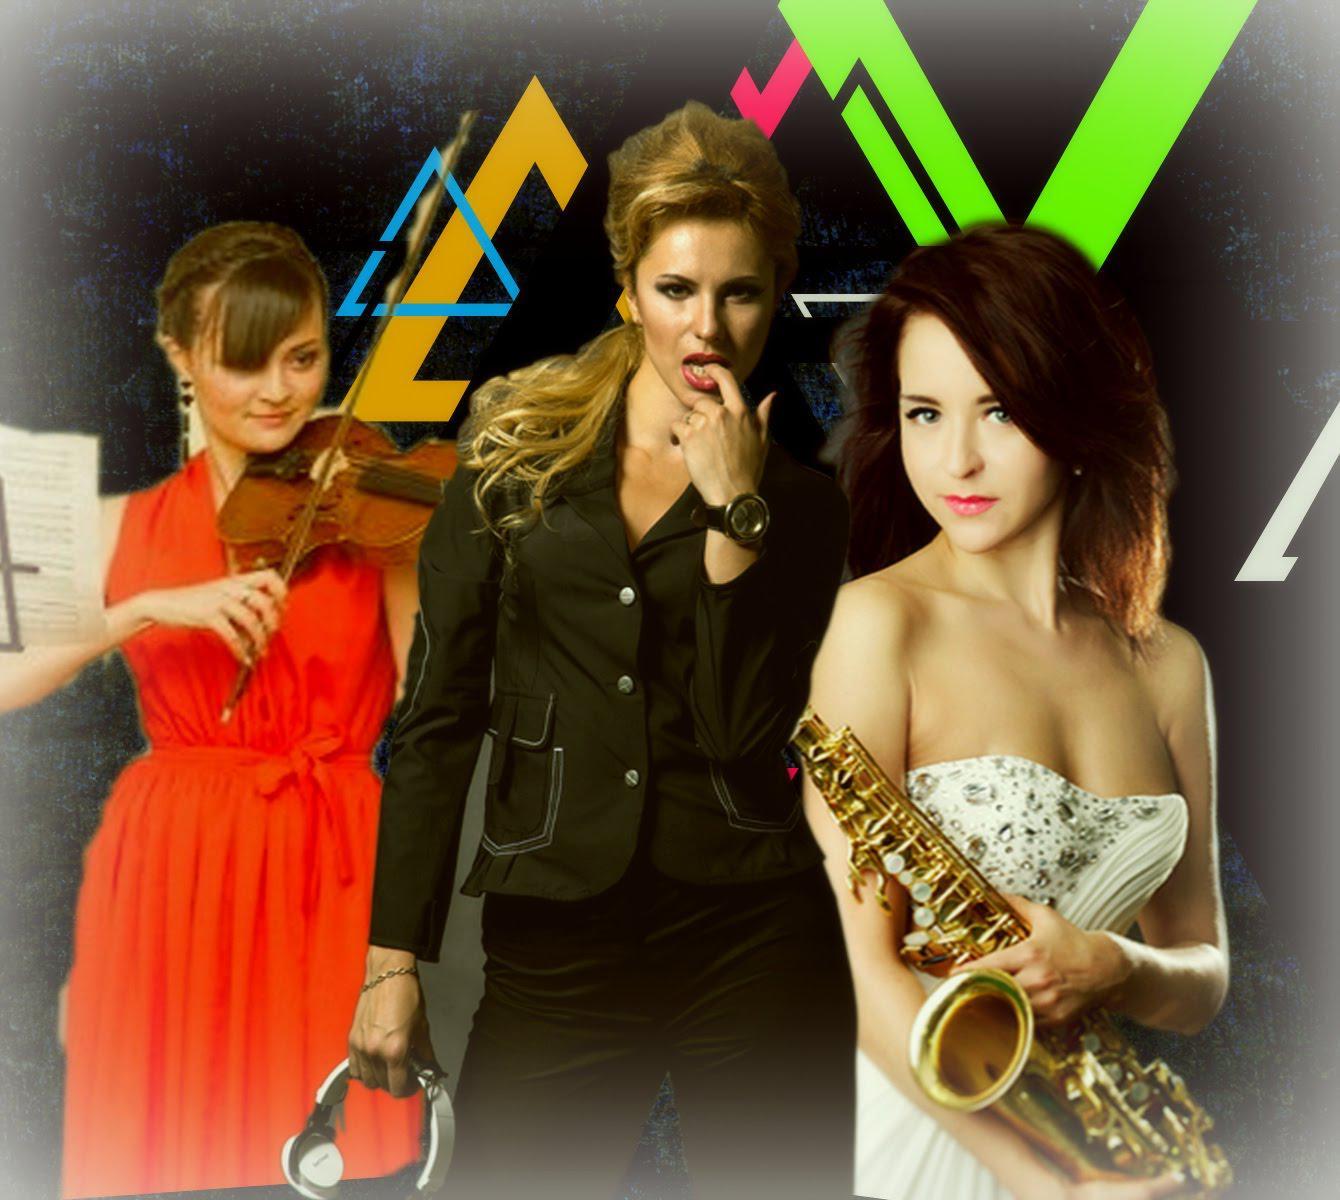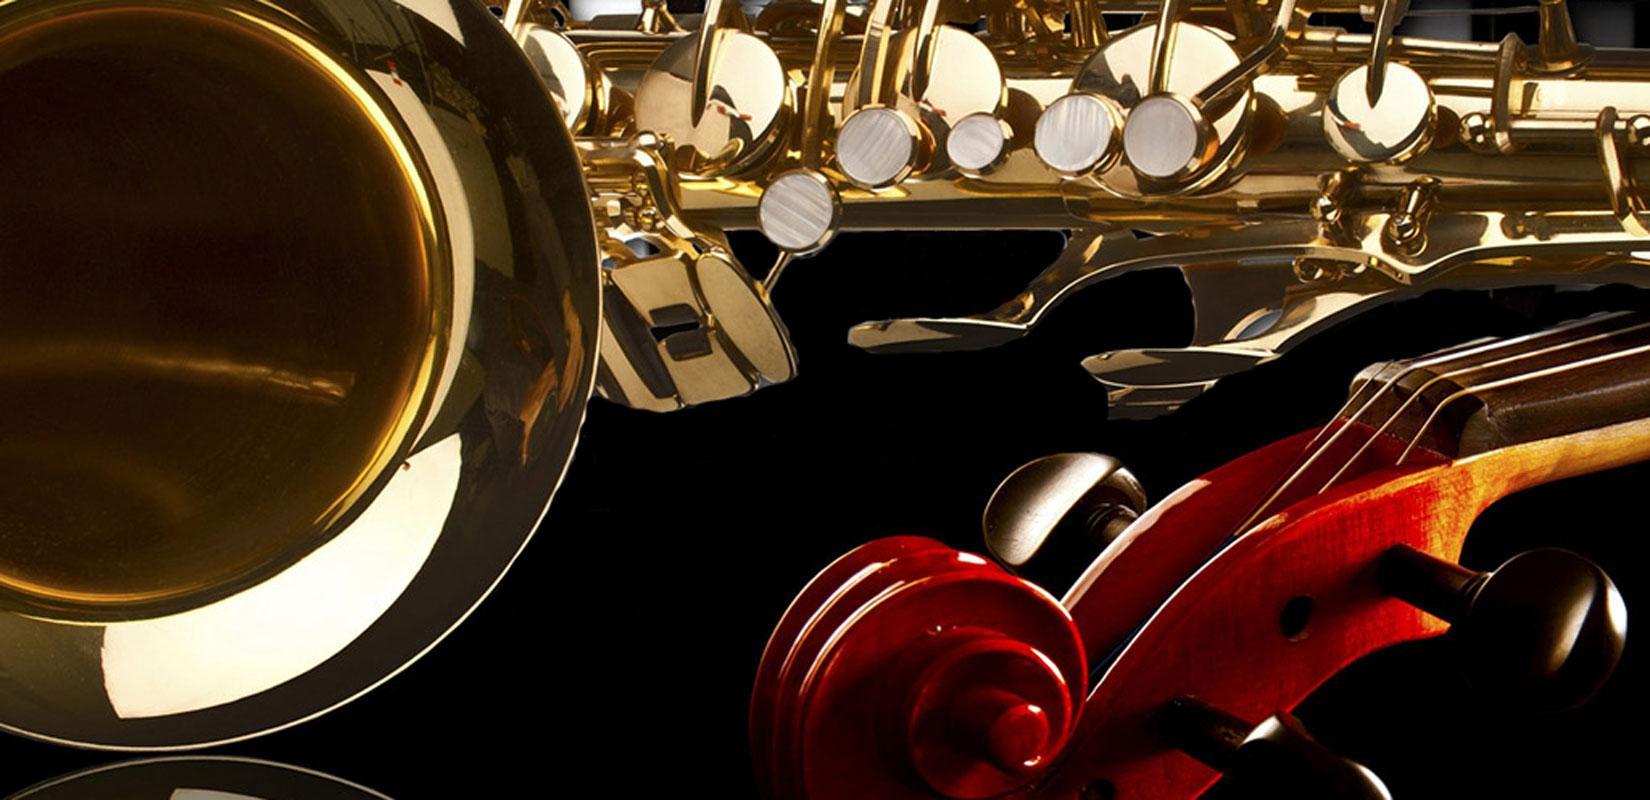The first image is the image on the left, the second image is the image on the right. Analyze the images presented: Is the assertion "There are exactly two people in the left image." valid? Answer yes or no. No. The first image is the image on the left, the second image is the image on the right. Assess this claim about the two images: "The lefthand image includes a woman in a cleavage-baring dress standing and holding a saxophone in front of a woman standing and playing violin.". Correct or not? Answer yes or no. Yes. 